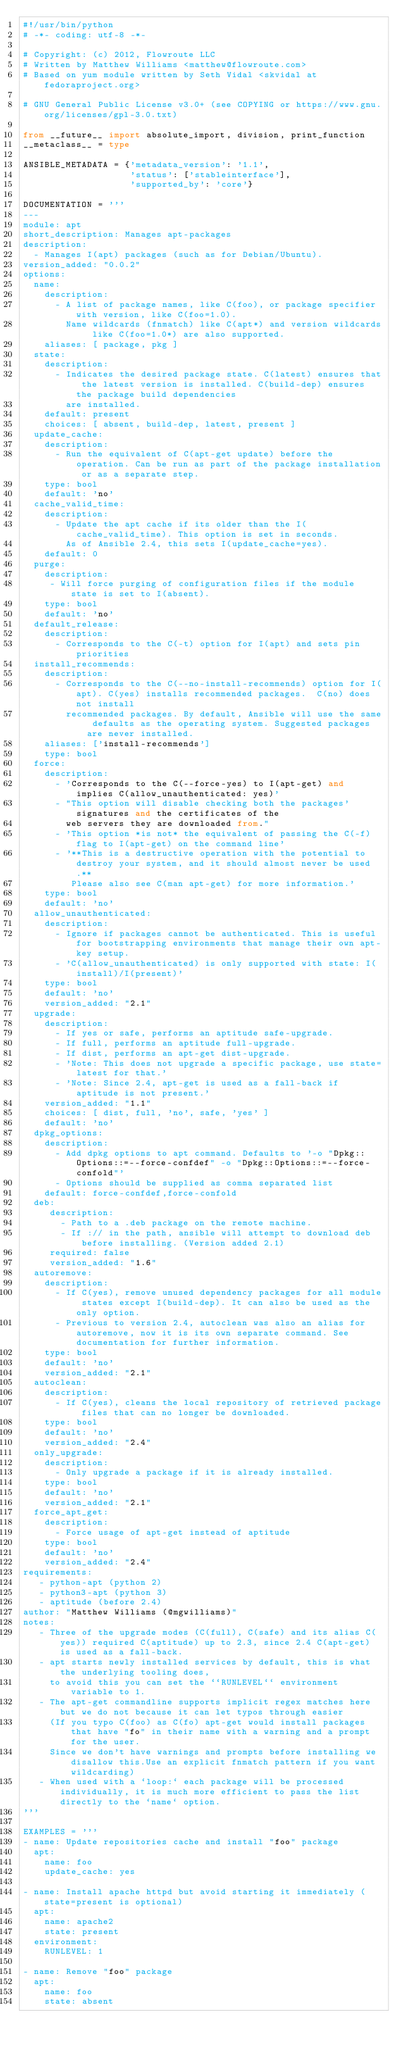Convert code to text. <code><loc_0><loc_0><loc_500><loc_500><_Python_>#!/usr/bin/python
# -*- coding: utf-8 -*-

# Copyright: (c) 2012, Flowroute LLC
# Written by Matthew Williams <matthew@flowroute.com>
# Based on yum module written by Seth Vidal <skvidal at fedoraproject.org>

# GNU General Public License v3.0+ (see COPYING or https://www.gnu.org/licenses/gpl-3.0.txt)

from __future__ import absolute_import, division, print_function
__metaclass__ = type

ANSIBLE_METADATA = {'metadata_version': '1.1',
                    'status': ['stableinterface'],
                    'supported_by': 'core'}

DOCUMENTATION = '''
---
module: apt
short_description: Manages apt-packages
description:
  - Manages I(apt) packages (such as for Debian/Ubuntu).
version_added: "0.0.2"
options:
  name:
    description:
      - A list of package names, like C(foo), or package specifier with version, like C(foo=1.0).
        Name wildcards (fnmatch) like C(apt*) and version wildcards like C(foo=1.0*) are also supported.
    aliases: [ package, pkg ]
  state:
    description:
      - Indicates the desired package state. C(latest) ensures that the latest version is installed. C(build-dep) ensures the package build dependencies
        are installed.
    default: present
    choices: [ absent, build-dep, latest, present ]
  update_cache:
    description:
      - Run the equivalent of C(apt-get update) before the operation. Can be run as part of the package installation or as a separate step.
    type: bool
    default: 'no'
  cache_valid_time:
    description:
      - Update the apt cache if its older than the I(cache_valid_time). This option is set in seconds.
        As of Ansible 2.4, this sets I(update_cache=yes).
    default: 0
  purge:
    description:
     - Will force purging of configuration files if the module state is set to I(absent).
    type: bool
    default: 'no'
  default_release:
    description:
      - Corresponds to the C(-t) option for I(apt) and sets pin priorities
  install_recommends:
    description:
      - Corresponds to the C(--no-install-recommends) option for I(apt). C(yes) installs recommended packages.  C(no) does not install
        recommended packages. By default, Ansible will use the same defaults as the operating system. Suggested packages are never installed.
    aliases: ['install-recommends']
    type: bool
  force:
    description:
      - 'Corresponds to the C(--force-yes) to I(apt-get) and implies C(allow_unauthenticated: yes)'
      - "This option will disable checking both the packages' signatures and the certificates of the
        web servers they are downloaded from."
      - 'This option *is not* the equivalent of passing the C(-f) flag to I(apt-get) on the command line'
      - '**This is a destructive operation with the potential to destroy your system, and it should almost never be used.**
         Please also see C(man apt-get) for more information.'
    type: bool
    default: 'no'
  allow_unauthenticated:
    description:
      - Ignore if packages cannot be authenticated. This is useful for bootstrapping environments that manage their own apt-key setup.
      - 'C(allow_unauthenticated) is only supported with state: I(install)/I(present)'
    type: bool
    default: 'no'
    version_added: "2.1"
  upgrade:
    description:
      - If yes or safe, performs an aptitude safe-upgrade.
      - If full, performs an aptitude full-upgrade.
      - If dist, performs an apt-get dist-upgrade.
      - 'Note: This does not upgrade a specific package, use state=latest for that.'
      - 'Note: Since 2.4, apt-get is used as a fall-back if aptitude is not present.'
    version_added: "1.1"
    choices: [ dist, full, 'no', safe, 'yes' ]
    default: 'no'
  dpkg_options:
    description:
      - Add dpkg options to apt command. Defaults to '-o "Dpkg::Options::=--force-confdef" -o "Dpkg::Options::=--force-confold"'
      - Options should be supplied as comma separated list
    default: force-confdef,force-confold
  deb:
     description:
       - Path to a .deb package on the remote machine.
       - If :// in the path, ansible will attempt to download deb before installing. (Version added 2.1)
     required: false
     version_added: "1.6"
  autoremove:
    description:
      - If C(yes), remove unused dependency packages for all module states except I(build-dep). It can also be used as the only option.
      - Previous to version 2.4, autoclean was also an alias for autoremove, now it is its own separate command. See documentation for further information.
    type: bool
    default: 'no'
    version_added: "2.1"
  autoclean:
    description:
      - If C(yes), cleans the local repository of retrieved package files that can no longer be downloaded.
    type: bool
    default: 'no'
    version_added: "2.4"
  only_upgrade:
    description:
      - Only upgrade a package if it is already installed.
    type: bool
    default: 'no'
    version_added: "2.1"
  force_apt_get:
    description:
      - Force usage of apt-get instead of aptitude
    type: bool
    default: 'no'
    version_added: "2.4"
requirements:
   - python-apt (python 2)
   - python3-apt (python 3)
   - aptitude (before 2.4)
author: "Matthew Williams (@mgwilliams)"
notes:
   - Three of the upgrade modes (C(full), C(safe) and its alias C(yes)) required C(aptitude) up to 2.3, since 2.4 C(apt-get) is used as a fall-back.
   - apt starts newly installed services by default, this is what the underlying tooling does,
     to avoid this you can set the ``RUNLEVEL`` environment variable to 1.
   - The apt-get commandline supports implicit regex matches here but we do not because it can let typos through easier
     (If you typo C(foo) as C(fo) apt-get would install packages that have "fo" in their name with a warning and a prompt for the user.
     Since we don't have warnings and prompts before installing we disallow this.Use an explicit fnmatch pattern if you want wildcarding)
   - When used with a `loop:` each package will be processed individually, it is much more efficient to pass the list directly to the `name` option.
'''

EXAMPLES = '''
- name: Update repositories cache and install "foo" package
  apt:
    name: foo
    update_cache: yes

- name: Install apache httpd but avoid starting it immediately (state=present is optional)
  apt:
    name: apache2
    state: present
  environment:
    RUNLEVEL: 1

- name: Remove "foo" package
  apt:
    name: foo
    state: absent
</code> 